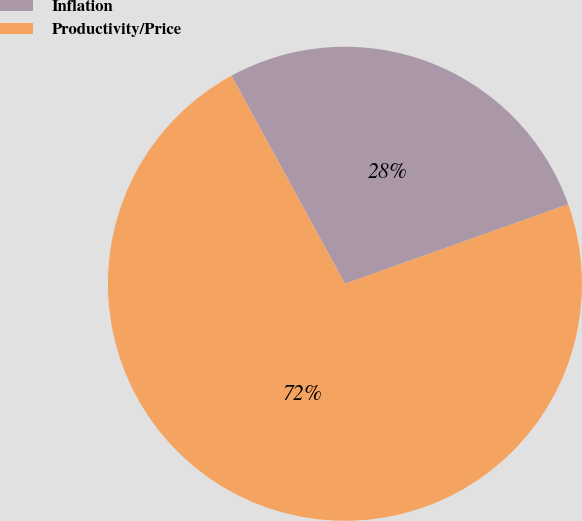Convert chart. <chart><loc_0><loc_0><loc_500><loc_500><pie_chart><fcel>Inflation<fcel>Productivity/Price<nl><fcel>27.5%<fcel>72.5%<nl></chart> 